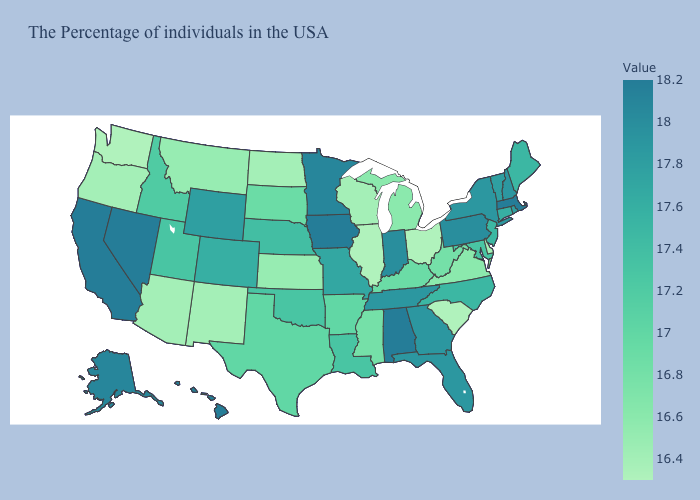Which states have the highest value in the USA?
Concise answer only. Massachusetts, Alabama, Iowa, Nevada, California, Hawaii. Which states have the lowest value in the South?
Be succinct. South Carolina. Does the map have missing data?
Be succinct. No. Among the states that border Minnesota , does South Dakota have the lowest value?
Give a very brief answer. No. 